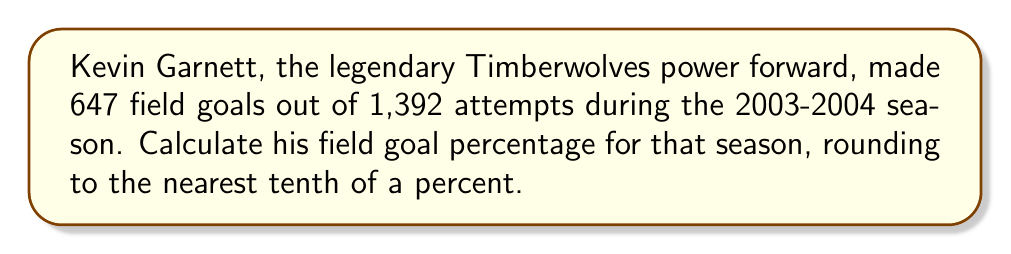Provide a solution to this math problem. To calculate Kevin Garnett's field goal percentage, we need to follow these steps:

1. Identify the given information:
   - Made field goals: 647
   - Attempted field goals: 1,392

2. Use the formula for field goal percentage:
   $$ \text{Field Goal Percentage} = \frac{\text{Made Field Goals}}{\text{Attempted Field Goals}} \times 100\% $$

3. Plug in the values:
   $$ \text{Field Goal Percentage} = \frac{647}{1,392} \times 100\% $$

4. Perform the division:
   $$ \frac{647}{1,392} \approx 0.4647887323943662 $$

5. Multiply by 100 to convert to a percentage:
   $$ 0.4647887323943662 \times 100\% \approx 46.47887323943662\% $$

6. Round to the nearest tenth of a percent:
   $$ 46.47887323943662\% \approx 46.5\% $$

Therefore, Kevin Garnett's field goal percentage for the 2003-2004 season was approximately 46.5%.
Answer: 46.5% 